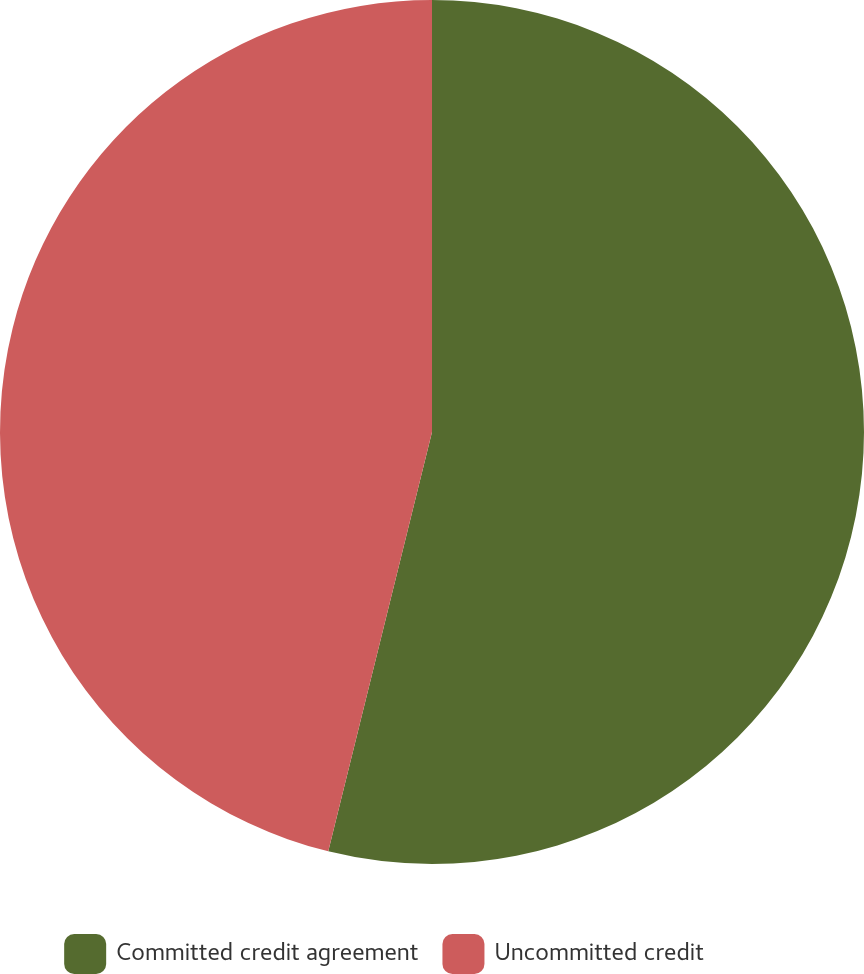Convert chart. <chart><loc_0><loc_0><loc_500><loc_500><pie_chart><fcel>Committed credit agreement<fcel>Uncommitted credit<nl><fcel>53.86%<fcel>46.14%<nl></chart> 